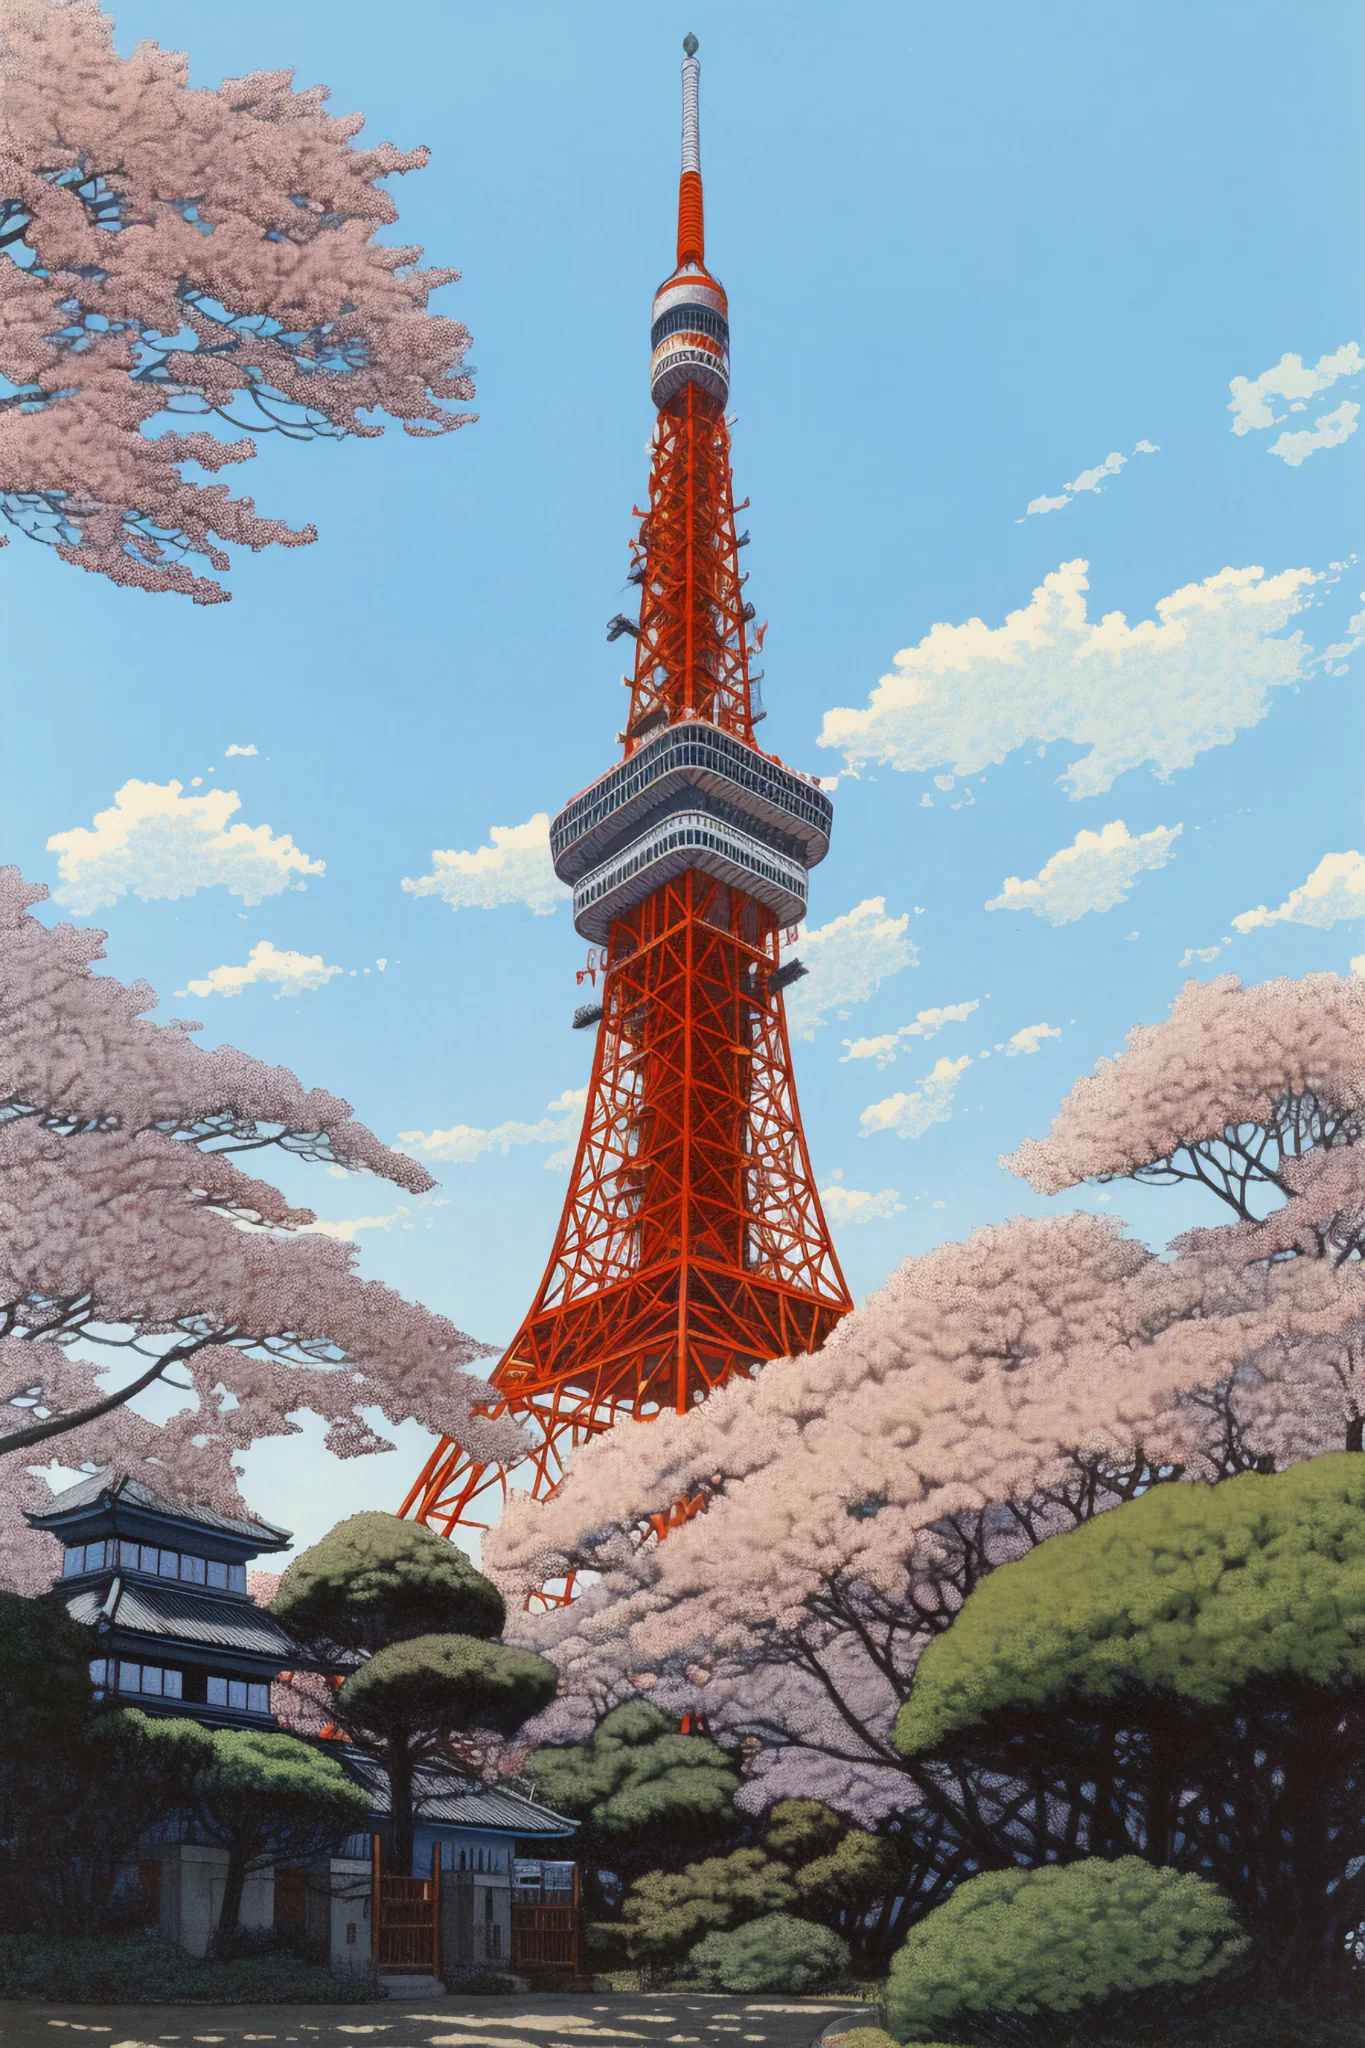What if this scene was part of a video game? Describe a potential gameplay scenario. In a video game, this vibrant Tokyo Tower setting could be a central hub for players. Imagine a game where players navigate a futuristic Tokyo and the tower serves as a high vantage point to scout the city. Players could engage in missions to protect the cherry blossoms from technological threats or rival factions, using both stealth and combat mechanics to navigate around the tower and its surrounding gardens. The tower itself could feature an intricate interior filled with hidden rooms, ancient artifacts, and challenging puzzles. Completing these missions would unlock special abilities or items that aid in the player's quest. Can you give an example of a mini-game that could take place here? One potential mini-game could be a cherry blossom collection challenge. As the blossoms fall gently from the trees, players must navigate the maze-like gardens and catch as many petals as possible within a time limit. Each petal collected could earn points, and special golden petals might provide bonus points or unique rewards. The mini-game could have various difficulty levels, with increasing obstacles or faster-falling petals as players progress. Successfully completing the mini-game might unlock special outfits or equipment inspired by the cherry blossoms. 